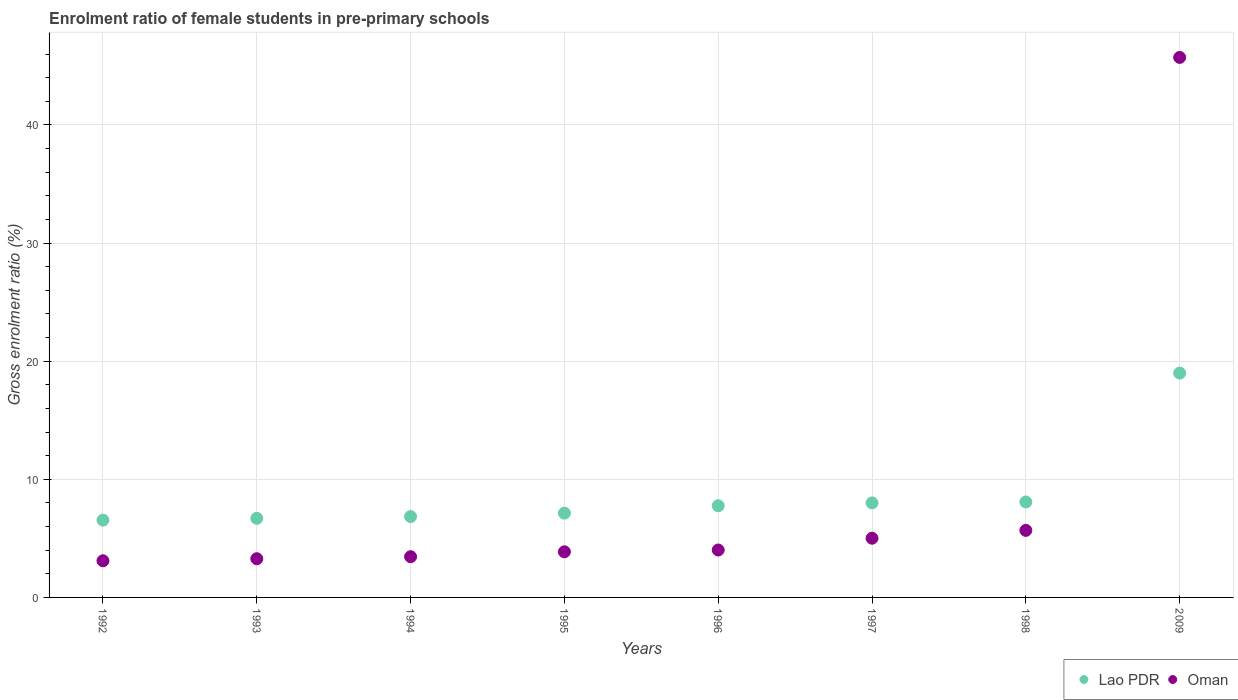How many different coloured dotlines are there?
Your answer should be very brief. 2. Is the number of dotlines equal to the number of legend labels?
Your response must be concise. Yes. What is the enrolment ratio of female students in pre-primary schools in Lao PDR in 1996?
Your response must be concise. 7.76. Across all years, what is the maximum enrolment ratio of female students in pre-primary schools in Oman?
Give a very brief answer. 45.72. Across all years, what is the minimum enrolment ratio of female students in pre-primary schools in Oman?
Ensure brevity in your answer.  3.1. In which year was the enrolment ratio of female students in pre-primary schools in Oman minimum?
Provide a short and direct response. 1992. What is the total enrolment ratio of female students in pre-primary schools in Oman in the graph?
Provide a succinct answer. 74.11. What is the difference between the enrolment ratio of female students in pre-primary schools in Oman in 1993 and that in 1994?
Your answer should be very brief. -0.17. What is the difference between the enrolment ratio of female students in pre-primary schools in Lao PDR in 1994 and the enrolment ratio of female students in pre-primary schools in Oman in 1995?
Provide a succinct answer. 2.98. What is the average enrolment ratio of female students in pre-primary schools in Lao PDR per year?
Give a very brief answer. 8.76. In the year 1997, what is the difference between the enrolment ratio of female students in pre-primary schools in Lao PDR and enrolment ratio of female students in pre-primary schools in Oman?
Your answer should be very brief. 2.99. What is the ratio of the enrolment ratio of female students in pre-primary schools in Oman in 1995 to that in 1997?
Offer a terse response. 0.77. Is the enrolment ratio of female students in pre-primary schools in Lao PDR in 1997 less than that in 2009?
Your answer should be compact. Yes. Is the difference between the enrolment ratio of female students in pre-primary schools in Lao PDR in 1993 and 1995 greater than the difference between the enrolment ratio of female students in pre-primary schools in Oman in 1993 and 1995?
Offer a terse response. Yes. What is the difference between the highest and the second highest enrolment ratio of female students in pre-primary schools in Lao PDR?
Your answer should be compact. 10.91. What is the difference between the highest and the lowest enrolment ratio of female students in pre-primary schools in Lao PDR?
Provide a succinct answer. 12.45. In how many years, is the enrolment ratio of female students in pre-primary schools in Lao PDR greater than the average enrolment ratio of female students in pre-primary schools in Lao PDR taken over all years?
Your answer should be compact. 1. Is the sum of the enrolment ratio of female students in pre-primary schools in Lao PDR in 1993 and 1995 greater than the maximum enrolment ratio of female students in pre-primary schools in Oman across all years?
Offer a terse response. No. Does the enrolment ratio of female students in pre-primary schools in Oman monotonically increase over the years?
Your answer should be compact. Yes. Is the enrolment ratio of female students in pre-primary schools in Lao PDR strictly less than the enrolment ratio of female students in pre-primary schools in Oman over the years?
Give a very brief answer. No. How many dotlines are there?
Provide a short and direct response. 2. How many years are there in the graph?
Offer a very short reply. 8. Are the values on the major ticks of Y-axis written in scientific E-notation?
Ensure brevity in your answer.  No. Does the graph contain grids?
Your response must be concise. Yes. What is the title of the graph?
Offer a very short reply. Enrolment ratio of female students in pre-primary schools. Does "Latvia" appear as one of the legend labels in the graph?
Offer a terse response. No. What is the label or title of the X-axis?
Provide a succinct answer. Years. What is the Gross enrolment ratio (%) in Lao PDR in 1992?
Keep it short and to the point. 6.54. What is the Gross enrolment ratio (%) of Oman in 1992?
Your answer should be compact. 3.1. What is the Gross enrolment ratio (%) of Lao PDR in 1993?
Your response must be concise. 6.7. What is the Gross enrolment ratio (%) in Oman in 1993?
Your answer should be compact. 3.28. What is the Gross enrolment ratio (%) of Lao PDR in 1994?
Offer a terse response. 6.85. What is the Gross enrolment ratio (%) in Oman in 1994?
Your response must be concise. 3.45. What is the Gross enrolment ratio (%) of Lao PDR in 1995?
Offer a very short reply. 7.14. What is the Gross enrolment ratio (%) of Oman in 1995?
Your response must be concise. 3.86. What is the Gross enrolment ratio (%) in Lao PDR in 1996?
Provide a short and direct response. 7.76. What is the Gross enrolment ratio (%) of Oman in 1996?
Provide a short and direct response. 4.01. What is the Gross enrolment ratio (%) of Lao PDR in 1997?
Provide a short and direct response. 8. What is the Gross enrolment ratio (%) of Oman in 1997?
Your answer should be compact. 5.01. What is the Gross enrolment ratio (%) in Lao PDR in 1998?
Your response must be concise. 8.08. What is the Gross enrolment ratio (%) in Oman in 1998?
Provide a succinct answer. 5.68. What is the Gross enrolment ratio (%) in Lao PDR in 2009?
Offer a very short reply. 18.99. What is the Gross enrolment ratio (%) in Oman in 2009?
Provide a succinct answer. 45.72. Across all years, what is the maximum Gross enrolment ratio (%) in Lao PDR?
Ensure brevity in your answer.  18.99. Across all years, what is the maximum Gross enrolment ratio (%) in Oman?
Your answer should be very brief. 45.72. Across all years, what is the minimum Gross enrolment ratio (%) of Lao PDR?
Your answer should be compact. 6.54. Across all years, what is the minimum Gross enrolment ratio (%) of Oman?
Give a very brief answer. 3.1. What is the total Gross enrolment ratio (%) in Lao PDR in the graph?
Give a very brief answer. 70.06. What is the total Gross enrolment ratio (%) of Oman in the graph?
Your response must be concise. 74.11. What is the difference between the Gross enrolment ratio (%) in Lao PDR in 1992 and that in 1993?
Keep it short and to the point. -0.15. What is the difference between the Gross enrolment ratio (%) of Oman in 1992 and that in 1993?
Provide a short and direct response. -0.18. What is the difference between the Gross enrolment ratio (%) in Lao PDR in 1992 and that in 1994?
Provide a succinct answer. -0.3. What is the difference between the Gross enrolment ratio (%) in Oman in 1992 and that in 1994?
Your answer should be very brief. -0.35. What is the difference between the Gross enrolment ratio (%) of Lao PDR in 1992 and that in 1995?
Offer a terse response. -0.59. What is the difference between the Gross enrolment ratio (%) in Oman in 1992 and that in 1995?
Make the answer very short. -0.76. What is the difference between the Gross enrolment ratio (%) in Lao PDR in 1992 and that in 1996?
Your response must be concise. -1.22. What is the difference between the Gross enrolment ratio (%) in Oman in 1992 and that in 1996?
Keep it short and to the point. -0.91. What is the difference between the Gross enrolment ratio (%) in Lao PDR in 1992 and that in 1997?
Ensure brevity in your answer.  -1.46. What is the difference between the Gross enrolment ratio (%) of Oman in 1992 and that in 1997?
Your response must be concise. -1.91. What is the difference between the Gross enrolment ratio (%) in Lao PDR in 1992 and that in 1998?
Offer a very short reply. -1.54. What is the difference between the Gross enrolment ratio (%) of Oman in 1992 and that in 1998?
Your answer should be very brief. -2.57. What is the difference between the Gross enrolment ratio (%) in Lao PDR in 1992 and that in 2009?
Your answer should be compact. -12.45. What is the difference between the Gross enrolment ratio (%) in Oman in 1992 and that in 2009?
Offer a terse response. -42.62. What is the difference between the Gross enrolment ratio (%) in Lao PDR in 1993 and that in 1994?
Give a very brief answer. -0.15. What is the difference between the Gross enrolment ratio (%) in Oman in 1993 and that in 1994?
Give a very brief answer. -0.17. What is the difference between the Gross enrolment ratio (%) in Lao PDR in 1993 and that in 1995?
Give a very brief answer. -0.44. What is the difference between the Gross enrolment ratio (%) in Oman in 1993 and that in 1995?
Ensure brevity in your answer.  -0.59. What is the difference between the Gross enrolment ratio (%) of Lao PDR in 1993 and that in 1996?
Make the answer very short. -1.06. What is the difference between the Gross enrolment ratio (%) in Oman in 1993 and that in 1996?
Make the answer very short. -0.74. What is the difference between the Gross enrolment ratio (%) of Lao PDR in 1993 and that in 1997?
Offer a very short reply. -1.3. What is the difference between the Gross enrolment ratio (%) of Oman in 1993 and that in 1997?
Your answer should be compact. -1.74. What is the difference between the Gross enrolment ratio (%) of Lao PDR in 1993 and that in 1998?
Your response must be concise. -1.38. What is the difference between the Gross enrolment ratio (%) of Oman in 1993 and that in 1998?
Your response must be concise. -2.4. What is the difference between the Gross enrolment ratio (%) in Lao PDR in 1993 and that in 2009?
Make the answer very short. -12.3. What is the difference between the Gross enrolment ratio (%) in Oman in 1993 and that in 2009?
Your answer should be very brief. -42.44. What is the difference between the Gross enrolment ratio (%) of Lao PDR in 1994 and that in 1995?
Make the answer very short. -0.29. What is the difference between the Gross enrolment ratio (%) of Oman in 1994 and that in 1995?
Your answer should be compact. -0.41. What is the difference between the Gross enrolment ratio (%) in Lao PDR in 1994 and that in 1996?
Your response must be concise. -0.92. What is the difference between the Gross enrolment ratio (%) in Oman in 1994 and that in 1996?
Your answer should be compact. -0.57. What is the difference between the Gross enrolment ratio (%) in Lao PDR in 1994 and that in 1997?
Provide a succinct answer. -1.16. What is the difference between the Gross enrolment ratio (%) of Oman in 1994 and that in 1997?
Provide a succinct answer. -1.56. What is the difference between the Gross enrolment ratio (%) in Lao PDR in 1994 and that in 1998?
Your answer should be compact. -1.24. What is the difference between the Gross enrolment ratio (%) of Oman in 1994 and that in 1998?
Ensure brevity in your answer.  -2.23. What is the difference between the Gross enrolment ratio (%) in Lao PDR in 1994 and that in 2009?
Ensure brevity in your answer.  -12.15. What is the difference between the Gross enrolment ratio (%) in Oman in 1994 and that in 2009?
Make the answer very short. -42.27. What is the difference between the Gross enrolment ratio (%) of Lao PDR in 1995 and that in 1996?
Keep it short and to the point. -0.63. What is the difference between the Gross enrolment ratio (%) of Oman in 1995 and that in 1996?
Your answer should be very brief. -0.15. What is the difference between the Gross enrolment ratio (%) of Lao PDR in 1995 and that in 1997?
Provide a succinct answer. -0.87. What is the difference between the Gross enrolment ratio (%) in Oman in 1995 and that in 1997?
Offer a terse response. -1.15. What is the difference between the Gross enrolment ratio (%) of Lao PDR in 1995 and that in 1998?
Your answer should be very brief. -0.95. What is the difference between the Gross enrolment ratio (%) of Oman in 1995 and that in 1998?
Keep it short and to the point. -1.81. What is the difference between the Gross enrolment ratio (%) of Lao PDR in 1995 and that in 2009?
Provide a succinct answer. -11.86. What is the difference between the Gross enrolment ratio (%) in Oman in 1995 and that in 2009?
Your answer should be very brief. -41.86. What is the difference between the Gross enrolment ratio (%) of Lao PDR in 1996 and that in 1997?
Offer a terse response. -0.24. What is the difference between the Gross enrolment ratio (%) in Oman in 1996 and that in 1997?
Ensure brevity in your answer.  -1. What is the difference between the Gross enrolment ratio (%) in Lao PDR in 1996 and that in 1998?
Offer a terse response. -0.32. What is the difference between the Gross enrolment ratio (%) of Oman in 1996 and that in 1998?
Your response must be concise. -1.66. What is the difference between the Gross enrolment ratio (%) of Lao PDR in 1996 and that in 2009?
Your answer should be very brief. -11.23. What is the difference between the Gross enrolment ratio (%) in Oman in 1996 and that in 2009?
Your answer should be compact. -41.71. What is the difference between the Gross enrolment ratio (%) in Lao PDR in 1997 and that in 1998?
Your answer should be very brief. -0.08. What is the difference between the Gross enrolment ratio (%) of Oman in 1997 and that in 1998?
Provide a succinct answer. -0.66. What is the difference between the Gross enrolment ratio (%) in Lao PDR in 1997 and that in 2009?
Your answer should be compact. -10.99. What is the difference between the Gross enrolment ratio (%) of Oman in 1997 and that in 2009?
Offer a terse response. -40.71. What is the difference between the Gross enrolment ratio (%) in Lao PDR in 1998 and that in 2009?
Ensure brevity in your answer.  -10.91. What is the difference between the Gross enrolment ratio (%) of Oman in 1998 and that in 2009?
Offer a terse response. -40.04. What is the difference between the Gross enrolment ratio (%) in Lao PDR in 1992 and the Gross enrolment ratio (%) in Oman in 1993?
Your answer should be very brief. 3.27. What is the difference between the Gross enrolment ratio (%) of Lao PDR in 1992 and the Gross enrolment ratio (%) of Oman in 1994?
Your answer should be very brief. 3.1. What is the difference between the Gross enrolment ratio (%) of Lao PDR in 1992 and the Gross enrolment ratio (%) of Oman in 1995?
Provide a short and direct response. 2.68. What is the difference between the Gross enrolment ratio (%) of Lao PDR in 1992 and the Gross enrolment ratio (%) of Oman in 1996?
Provide a succinct answer. 2.53. What is the difference between the Gross enrolment ratio (%) in Lao PDR in 1992 and the Gross enrolment ratio (%) in Oman in 1997?
Your response must be concise. 1.53. What is the difference between the Gross enrolment ratio (%) of Lao PDR in 1992 and the Gross enrolment ratio (%) of Oman in 1998?
Keep it short and to the point. 0.87. What is the difference between the Gross enrolment ratio (%) of Lao PDR in 1992 and the Gross enrolment ratio (%) of Oman in 2009?
Make the answer very short. -39.17. What is the difference between the Gross enrolment ratio (%) in Lao PDR in 1993 and the Gross enrolment ratio (%) in Oman in 1995?
Give a very brief answer. 2.84. What is the difference between the Gross enrolment ratio (%) in Lao PDR in 1993 and the Gross enrolment ratio (%) in Oman in 1996?
Your answer should be compact. 2.68. What is the difference between the Gross enrolment ratio (%) of Lao PDR in 1993 and the Gross enrolment ratio (%) of Oman in 1997?
Ensure brevity in your answer.  1.69. What is the difference between the Gross enrolment ratio (%) in Lao PDR in 1993 and the Gross enrolment ratio (%) in Oman in 1998?
Keep it short and to the point. 1.02. What is the difference between the Gross enrolment ratio (%) in Lao PDR in 1993 and the Gross enrolment ratio (%) in Oman in 2009?
Provide a short and direct response. -39.02. What is the difference between the Gross enrolment ratio (%) of Lao PDR in 1994 and the Gross enrolment ratio (%) of Oman in 1995?
Your answer should be compact. 2.98. What is the difference between the Gross enrolment ratio (%) in Lao PDR in 1994 and the Gross enrolment ratio (%) in Oman in 1996?
Your response must be concise. 2.83. What is the difference between the Gross enrolment ratio (%) of Lao PDR in 1994 and the Gross enrolment ratio (%) of Oman in 1997?
Your answer should be compact. 1.83. What is the difference between the Gross enrolment ratio (%) of Lao PDR in 1994 and the Gross enrolment ratio (%) of Oman in 1998?
Ensure brevity in your answer.  1.17. What is the difference between the Gross enrolment ratio (%) of Lao PDR in 1994 and the Gross enrolment ratio (%) of Oman in 2009?
Your answer should be very brief. -38.87. What is the difference between the Gross enrolment ratio (%) of Lao PDR in 1995 and the Gross enrolment ratio (%) of Oman in 1996?
Provide a short and direct response. 3.12. What is the difference between the Gross enrolment ratio (%) in Lao PDR in 1995 and the Gross enrolment ratio (%) in Oman in 1997?
Your response must be concise. 2.12. What is the difference between the Gross enrolment ratio (%) in Lao PDR in 1995 and the Gross enrolment ratio (%) in Oman in 1998?
Your answer should be very brief. 1.46. What is the difference between the Gross enrolment ratio (%) of Lao PDR in 1995 and the Gross enrolment ratio (%) of Oman in 2009?
Ensure brevity in your answer.  -38.58. What is the difference between the Gross enrolment ratio (%) of Lao PDR in 1996 and the Gross enrolment ratio (%) of Oman in 1997?
Your response must be concise. 2.75. What is the difference between the Gross enrolment ratio (%) of Lao PDR in 1996 and the Gross enrolment ratio (%) of Oman in 1998?
Your answer should be very brief. 2.09. What is the difference between the Gross enrolment ratio (%) in Lao PDR in 1996 and the Gross enrolment ratio (%) in Oman in 2009?
Your response must be concise. -37.96. What is the difference between the Gross enrolment ratio (%) of Lao PDR in 1997 and the Gross enrolment ratio (%) of Oman in 1998?
Give a very brief answer. 2.33. What is the difference between the Gross enrolment ratio (%) of Lao PDR in 1997 and the Gross enrolment ratio (%) of Oman in 2009?
Provide a short and direct response. -37.72. What is the difference between the Gross enrolment ratio (%) of Lao PDR in 1998 and the Gross enrolment ratio (%) of Oman in 2009?
Offer a very short reply. -37.64. What is the average Gross enrolment ratio (%) in Lao PDR per year?
Offer a terse response. 8.76. What is the average Gross enrolment ratio (%) of Oman per year?
Your response must be concise. 9.26. In the year 1992, what is the difference between the Gross enrolment ratio (%) in Lao PDR and Gross enrolment ratio (%) in Oman?
Keep it short and to the point. 3.44. In the year 1993, what is the difference between the Gross enrolment ratio (%) of Lao PDR and Gross enrolment ratio (%) of Oman?
Make the answer very short. 3.42. In the year 1994, what is the difference between the Gross enrolment ratio (%) in Lao PDR and Gross enrolment ratio (%) in Oman?
Your answer should be compact. 3.4. In the year 1995, what is the difference between the Gross enrolment ratio (%) in Lao PDR and Gross enrolment ratio (%) in Oman?
Provide a succinct answer. 3.27. In the year 1996, what is the difference between the Gross enrolment ratio (%) of Lao PDR and Gross enrolment ratio (%) of Oman?
Provide a short and direct response. 3.75. In the year 1997, what is the difference between the Gross enrolment ratio (%) in Lao PDR and Gross enrolment ratio (%) in Oman?
Your response must be concise. 2.99. In the year 1998, what is the difference between the Gross enrolment ratio (%) in Lao PDR and Gross enrolment ratio (%) in Oman?
Keep it short and to the point. 2.41. In the year 2009, what is the difference between the Gross enrolment ratio (%) of Lao PDR and Gross enrolment ratio (%) of Oman?
Your answer should be compact. -26.72. What is the ratio of the Gross enrolment ratio (%) in Lao PDR in 1992 to that in 1993?
Provide a short and direct response. 0.98. What is the ratio of the Gross enrolment ratio (%) of Oman in 1992 to that in 1993?
Your answer should be very brief. 0.95. What is the ratio of the Gross enrolment ratio (%) of Lao PDR in 1992 to that in 1994?
Make the answer very short. 0.96. What is the ratio of the Gross enrolment ratio (%) in Oman in 1992 to that in 1994?
Offer a terse response. 0.9. What is the ratio of the Gross enrolment ratio (%) in Lao PDR in 1992 to that in 1995?
Give a very brief answer. 0.92. What is the ratio of the Gross enrolment ratio (%) in Oman in 1992 to that in 1995?
Provide a short and direct response. 0.8. What is the ratio of the Gross enrolment ratio (%) in Lao PDR in 1992 to that in 1996?
Make the answer very short. 0.84. What is the ratio of the Gross enrolment ratio (%) of Oman in 1992 to that in 1996?
Provide a succinct answer. 0.77. What is the ratio of the Gross enrolment ratio (%) of Lao PDR in 1992 to that in 1997?
Your answer should be compact. 0.82. What is the ratio of the Gross enrolment ratio (%) of Oman in 1992 to that in 1997?
Provide a short and direct response. 0.62. What is the ratio of the Gross enrolment ratio (%) of Lao PDR in 1992 to that in 1998?
Your response must be concise. 0.81. What is the ratio of the Gross enrolment ratio (%) of Oman in 1992 to that in 1998?
Offer a terse response. 0.55. What is the ratio of the Gross enrolment ratio (%) of Lao PDR in 1992 to that in 2009?
Provide a short and direct response. 0.34. What is the ratio of the Gross enrolment ratio (%) in Oman in 1992 to that in 2009?
Keep it short and to the point. 0.07. What is the ratio of the Gross enrolment ratio (%) of Lao PDR in 1993 to that in 1994?
Make the answer very short. 0.98. What is the ratio of the Gross enrolment ratio (%) in Oman in 1993 to that in 1994?
Your answer should be compact. 0.95. What is the ratio of the Gross enrolment ratio (%) of Lao PDR in 1993 to that in 1995?
Provide a succinct answer. 0.94. What is the ratio of the Gross enrolment ratio (%) of Oman in 1993 to that in 1995?
Keep it short and to the point. 0.85. What is the ratio of the Gross enrolment ratio (%) in Lao PDR in 1993 to that in 1996?
Ensure brevity in your answer.  0.86. What is the ratio of the Gross enrolment ratio (%) of Oman in 1993 to that in 1996?
Your answer should be compact. 0.82. What is the ratio of the Gross enrolment ratio (%) in Lao PDR in 1993 to that in 1997?
Your response must be concise. 0.84. What is the ratio of the Gross enrolment ratio (%) in Oman in 1993 to that in 1997?
Keep it short and to the point. 0.65. What is the ratio of the Gross enrolment ratio (%) in Lao PDR in 1993 to that in 1998?
Make the answer very short. 0.83. What is the ratio of the Gross enrolment ratio (%) in Oman in 1993 to that in 1998?
Offer a very short reply. 0.58. What is the ratio of the Gross enrolment ratio (%) in Lao PDR in 1993 to that in 2009?
Ensure brevity in your answer.  0.35. What is the ratio of the Gross enrolment ratio (%) in Oman in 1993 to that in 2009?
Your answer should be very brief. 0.07. What is the ratio of the Gross enrolment ratio (%) in Lao PDR in 1994 to that in 1995?
Provide a succinct answer. 0.96. What is the ratio of the Gross enrolment ratio (%) of Oman in 1994 to that in 1995?
Keep it short and to the point. 0.89. What is the ratio of the Gross enrolment ratio (%) of Lao PDR in 1994 to that in 1996?
Give a very brief answer. 0.88. What is the ratio of the Gross enrolment ratio (%) in Oman in 1994 to that in 1996?
Provide a short and direct response. 0.86. What is the ratio of the Gross enrolment ratio (%) of Lao PDR in 1994 to that in 1997?
Offer a very short reply. 0.86. What is the ratio of the Gross enrolment ratio (%) of Oman in 1994 to that in 1997?
Your answer should be very brief. 0.69. What is the ratio of the Gross enrolment ratio (%) of Lao PDR in 1994 to that in 1998?
Your response must be concise. 0.85. What is the ratio of the Gross enrolment ratio (%) of Oman in 1994 to that in 1998?
Your answer should be very brief. 0.61. What is the ratio of the Gross enrolment ratio (%) in Lao PDR in 1994 to that in 2009?
Your answer should be compact. 0.36. What is the ratio of the Gross enrolment ratio (%) of Oman in 1994 to that in 2009?
Keep it short and to the point. 0.08. What is the ratio of the Gross enrolment ratio (%) in Lao PDR in 1995 to that in 1996?
Your answer should be very brief. 0.92. What is the ratio of the Gross enrolment ratio (%) of Oman in 1995 to that in 1996?
Keep it short and to the point. 0.96. What is the ratio of the Gross enrolment ratio (%) of Lao PDR in 1995 to that in 1997?
Your response must be concise. 0.89. What is the ratio of the Gross enrolment ratio (%) of Oman in 1995 to that in 1997?
Keep it short and to the point. 0.77. What is the ratio of the Gross enrolment ratio (%) of Lao PDR in 1995 to that in 1998?
Provide a succinct answer. 0.88. What is the ratio of the Gross enrolment ratio (%) of Oman in 1995 to that in 1998?
Make the answer very short. 0.68. What is the ratio of the Gross enrolment ratio (%) in Lao PDR in 1995 to that in 2009?
Your answer should be compact. 0.38. What is the ratio of the Gross enrolment ratio (%) in Oman in 1995 to that in 2009?
Make the answer very short. 0.08. What is the ratio of the Gross enrolment ratio (%) of Lao PDR in 1996 to that in 1997?
Make the answer very short. 0.97. What is the ratio of the Gross enrolment ratio (%) in Oman in 1996 to that in 1997?
Your answer should be compact. 0.8. What is the ratio of the Gross enrolment ratio (%) of Lao PDR in 1996 to that in 1998?
Offer a terse response. 0.96. What is the ratio of the Gross enrolment ratio (%) of Oman in 1996 to that in 1998?
Your response must be concise. 0.71. What is the ratio of the Gross enrolment ratio (%) in Lao PDR in 1996 to that in 2009?
Give a very brief answer. 0.41. What is the ratio of the Gross enrolment ratio (%) in Oman in 1996 to that in 2009?
Give a very brief answer. 0.09. What is the ratio of the Gross enrolment ratio (%) of Lao PDR in 1997 to that in 1998?
Give a very brief answer. 0.99. What is the ratio of the Gross enrolment ratio (%) of Oman in 1997 to that in 1998?
Provide a short and direct response. 0.88. What is the ratio of the Gross enrolment ratio (%) in Lao PDR in 1997 to that in 2009?
Keep it short and to the point. 0.42. What is the ratio of the Gross enrolment ratio (%) of Oman in 1997 to that in 2009?
Offer a very short reply. 0.11. What is the ratio of the Gross enrolment ratio (%) of Lao PDR in 1998 to that in 2009?
Keep it short and to the point. 0.43. What is the ratio of the Gross enrolment ratio (%) in Oman in 1998 to that in 2009?
Ensure brevity in your answer.  0.12. What is the difference between the highest and the second highest Gross enrolment ratio (%) in Lao PDR?
Give a very brief answer. 10.91. What is the difference between the highest and the second highest Gross enrolment ratio (%) of Oman?
Your response must be concise. 40.04. What is the difference between the highest and the lowest Gross enrolment ratio (%) in Lao PDR?
Provide a short and direct response. 12.45. What is the difference between the highest and the lowest Gross enrolment ratio (%) of Oman?
Ensure brevity in your answer.  42.62. 